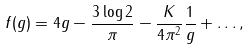<formula> <loc_0><loc_0><loc_500><loc_500>f ( g ) = 4 g - \frac { 3 \log 2 } { \pi } - \frac { K } { 4 \pi ^ { 2 } } \frac { 1 } { g } + \dots ,</formula> 